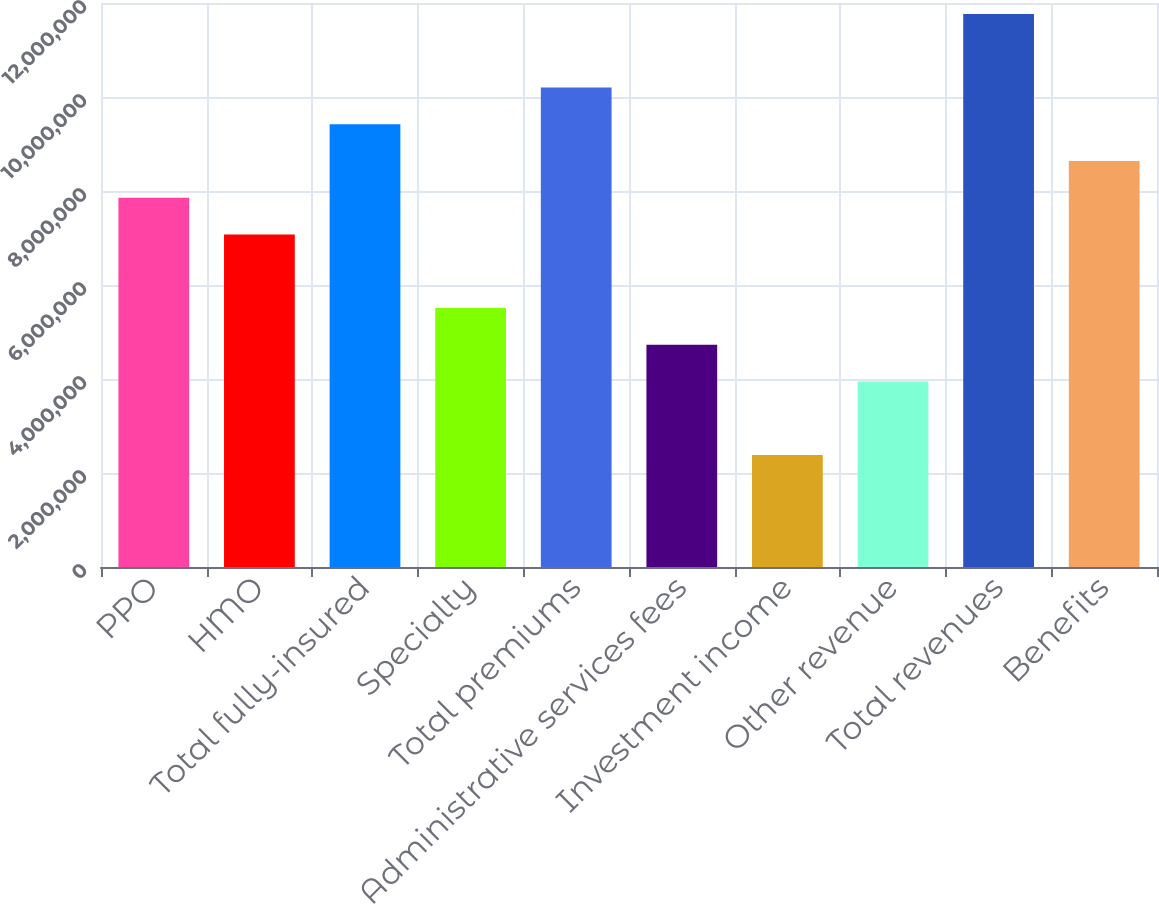<chart> <loc_0><loc_0><loc_500><loc_500><bar_chart><fcel>PPO<fcel>HMO<fcel>Total fully-insured<fcel>Specialty<fcel>Total premiums<fcel>Administrative services fees<fcel>Investment income<fcel>Other revenue<fcel>Total revenues<fcel>Benefits<nl><fcel>7.85547e+06<fcel>7.07361e+06<fcel>9.4192e+06<fcel>5.50988e+06<fcel>1.02011e+07<fcel>4.72801e+06<fcel>2.38242e+06<fcel>3.94615e+06<fcel>1.17648e+07<fcel>8.63733e+06<nl></chart> 